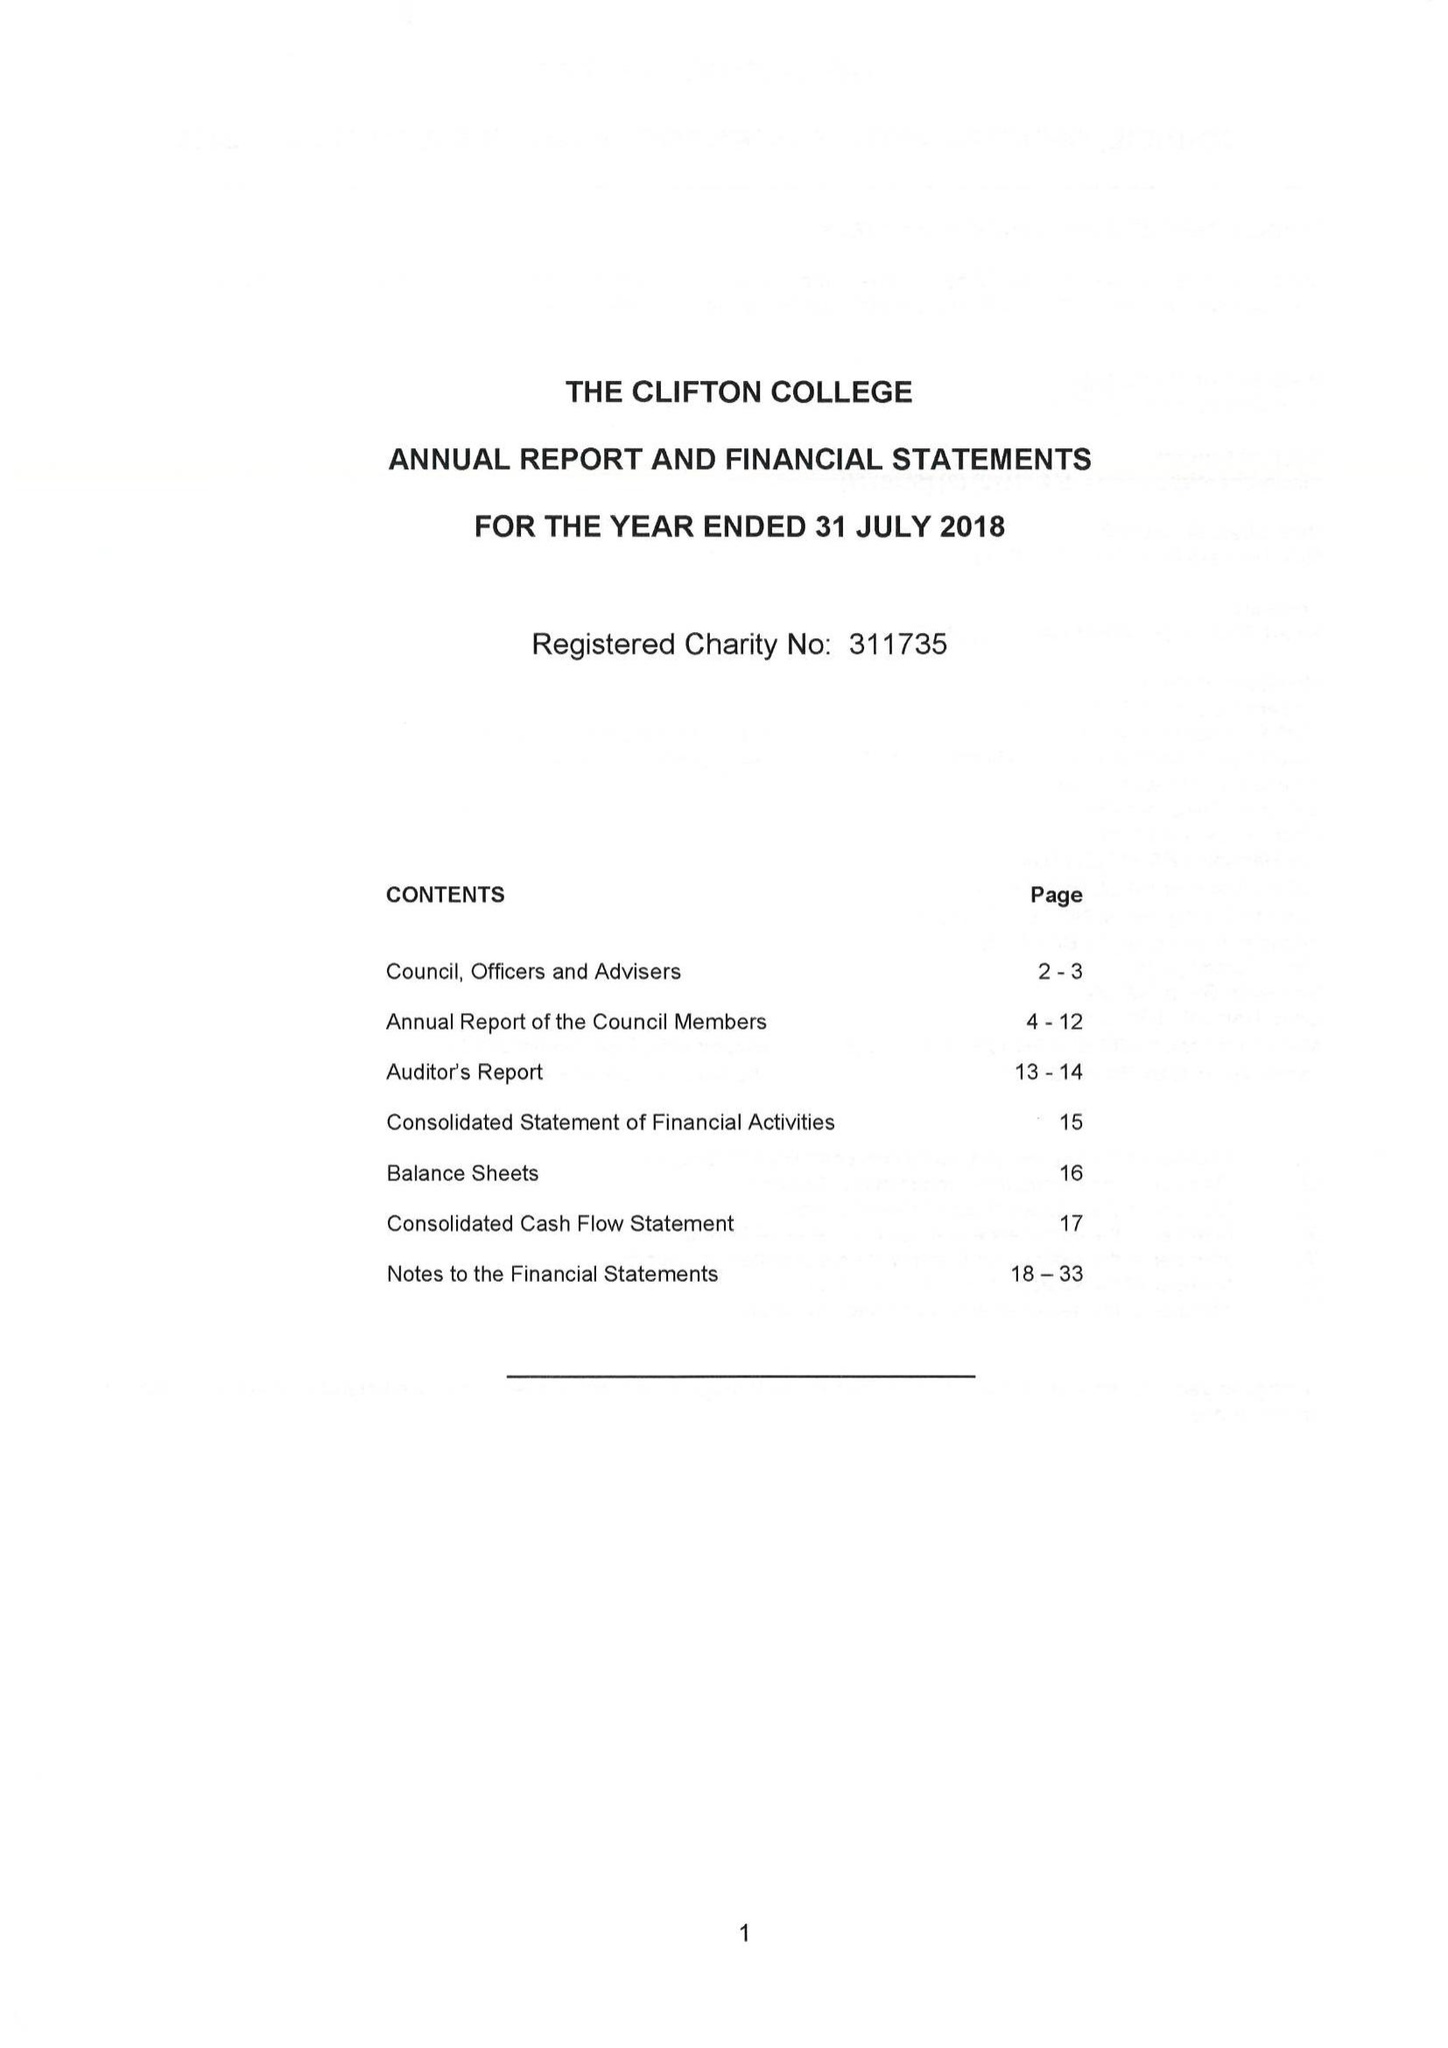What is the value for the address__postcode?
Answer the question using a single word or phrase. BS8 3JH 